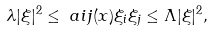<formula> <loc_0><loc_0><loc_500><loc_500>& \lambda | \xi | ^ { 2 } \leq \ a i j ( x ) \xi _ { i } \xi _ { j } \leq \Lambda | \xi | ^ { 2 } ,</formula> 